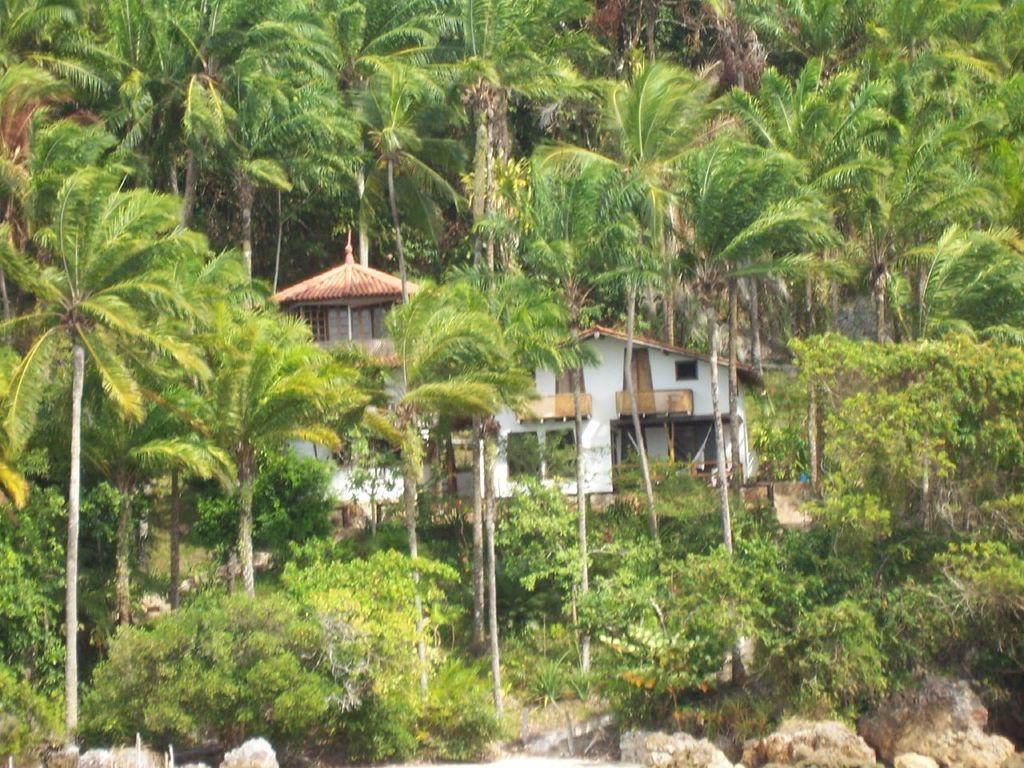What type of structure is present in the image? There is a building in the image. What natural elements can be seen in the image? There are trees, plants, and grass visible in the image. What type of ground cover is present at the bottom of the image? There are stones visible at the bottom of the image. What grade is the building in the image? The provided facts do not mention the grade or any other information about the building's classification. --- 